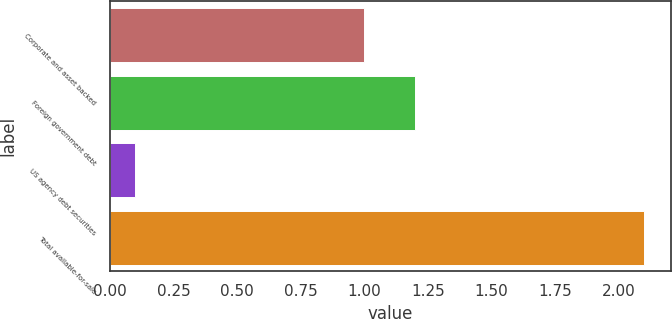Convert chart. <chart><loc_0><loc_0><loc_500><loc_500><bar_chart><fcel>Corporate and asset backed<fcel>Foreign government debt<fcel>US agency debt securities<fcel>Total available-for-sale<nl><fcel>1<fcel>1.2<fcel>0.1<fcel>2.1<nl></chart> 